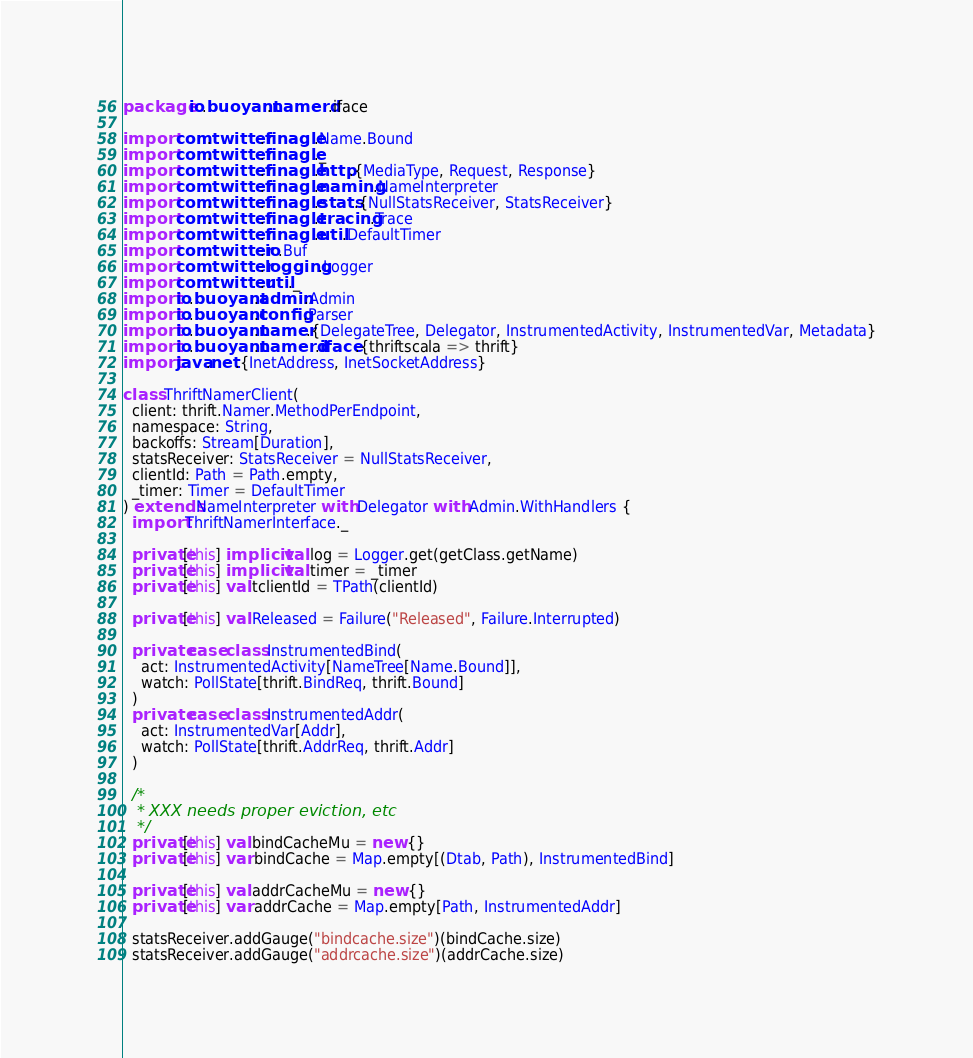Convert code to text. <code><loc_0><loc_0><loc_500><loc_500><_Scala_>package io.buoyant.namerd.iface

import com.twitter.finagle.Name.Bound
import com.twitter.finagle._
import com.twitter.finagle.http.{MediaType, Request, Response}
import com.twitter.finagle.naming.NameInterpreter
import com.twitter.finagle.stats.{NullStatsReceiver, StatsReceiver}
import com.twitter.finagle.tracing.Trace
import com.twitter.finagle.util.DefaultTimer
import com.twitter.io.Buf
import com.twitter.logging.Logger
import com.twitter.util._
import io.buoyant.admin.Admin
import io.buoyant.config.Parser
import io.buoyant.namer.{DelegateTree, Delegator, InstrumentedActivity, InstrumentedVar, Metadata}
import io.buoyant.namerd.iface.{thriftscala => thrift}
import java.net.{InetAddress, InetSocketAddress}

class ThriftNamerClient(
  client: thrift.Namer.MethodPerEndpoint,
  namespace: String,
  backoffs: Stream[Duration],
  statsReceiver: StatsReceiver = NullStatsReceiver,
  clientId: Path = Path.empty,
  _timer: Timer = DefaultTimer
) extends NameInterpreter with Delegator with Admin.WithHandlers {
  import ThriftNamerInterface._

  private[this] implicit val log = Logger.get(getClass.getName)
  private[this] implicit val timer = _timer
  private[this] val tclientId = TPath(clientId)

  private[this] val Released = Failure("Released", Failure.Interrupted)

  private case class InstrumentedBind(
    act: InstrumentedActivity[NameTree[Name.Bound]],
    watch: PollState[thrift.BindReq, thrift.Bound]
  )
  private case class InstrumentedAddr(
    act: InstrumentedVar[Addr],
    watch: PollState[thrift.AddrReq, thrift.Addr]
  )

  /*
   * XXX needs proper eviction, etc
   */
  private[this] val bindCacheMu = new {}
  private[this] var bindCache = Map.empty[(Dtab, Path), InstrumentedBind]

  private[this] val addrCacheMu = new {}
  private[this] var addrCache = Map.empty[Path, InstrumentedAddr]

  statsReceiver.addGauge("bindcache.size")(bindCache.size)
  statsReceiver.addGauge("addrcache.size")(addrCache.size)
</code> 